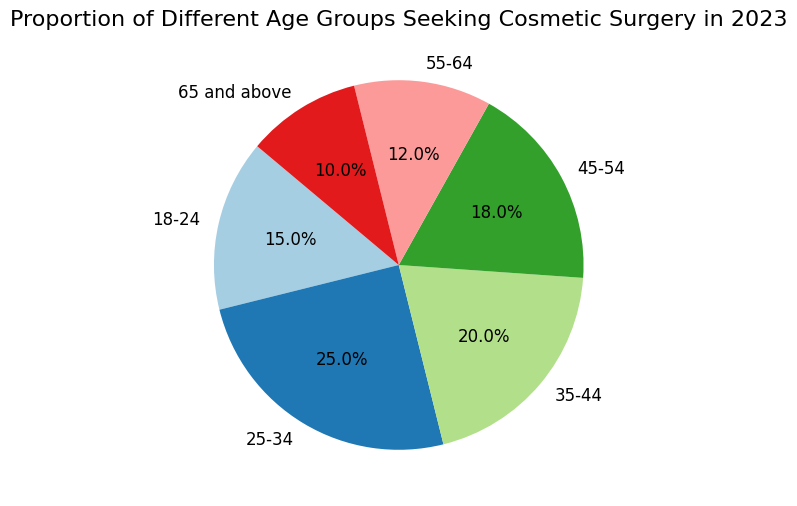What's the total proportion of people seeking cosmetic surgery who are 35 years old or older? Sum the proportions of age groups 35-44, 45-54, 55-64, and 65 and above: 20% + 18% + 12% + 10% = 60%
Answer: 60% Which age group represents the highest proportion of people seeking cosmetic surgery? Identify the age group with the largest proportion value in the figure. The 25-34 age group has the highest proportion at 25%
Answer: 25-34 Is the proportion of the 18-24 age group seeking cosmetic surgery less than that of the 45-54 age group? Compare proportions for the 18-24 and 45-54 age groups. 18-24 is 15% and 45-54 is 18%, so 15% < 18%
Answer: Yes How much more likely are people aged 25-34 to seek cosmetic surgery compared to those aged 55-64? Subtract the proportion of the 55-64 age group (12%) from the 25-34 age group (25%): 25% - 12% = 13%
Answer: 13% more likely Which two adjacent age groups have the smallest difference in their proportions? Calculate the differences between adjacent age groups: 
(25-34) - (18-24) = 25% - 15% = 10%, 
(35-44) - (25-34) = 20% - 25% = 5%, 
(45-54) - (35-44) = 18% - 20% = 2%, 
(55-64) - (45-54) = 12% - 18% = 6%, 
(65 and above) - (55-64) = 10% - 12% = 2%. 
The smallest difference is between 45-54 & 35-44 at 2% or 65 and above & 55-64 at 2%
Answer: 45-54 & 35-44, 65 and above & 55-64 How does the proportion of people aged 65 and above compare to the proportion of people aged 18-24? Compare the proportions directly: 65 and above has 10% and 18-24 has 15%, so 10% < 15%
Answer: Less What is the average proportion of people aged between 25 to 54 (inclusive) seeking cosmetic surgery? Calculate the average of the proportions for the 25-34, 35-44, and 45-54 age groups: (25% + 20% + 18%) / 3 = 63% / 3 = 21%
Answer: 21% If we combine the proportions of the youngest and oldest age groups (18-24 and 65 and above), what is the resulting proportion? Sum the proportions for the 18-24 and 65 and above age groups: 15% + 10% = 25%
Answer: 25% Which age group represents the smallest proportion of people seeking cosmetic surgery? Identify the age group with the smallest proportion value in the figure. The 65 and above age group has the smallest proportion at 10%
Answer: 65 and above What percentage more people in the 25-34 age group are seeking cosmetic surgery compared to the 55-64 age group? Calculate the percentage increase from the proportion for 55-64 to 25-34: 
((25% - 12%) / 12%) * 100% = (13% / 12%) * 100% ≈ 108.3%
Answer: 108.3% 